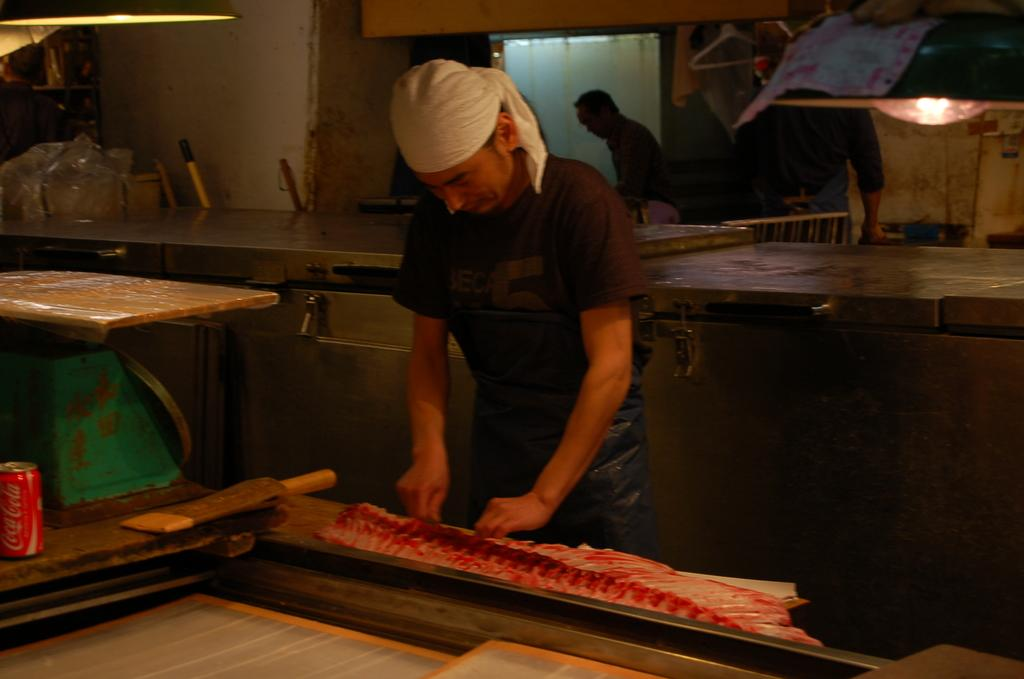What is the man in the image doing? The man in the image is cutting meat. What object can be seen on the table in the image? There is a tin on the table in the image. Can you describe the people in the background of the image? There are two people in the background of the image. What can be used to provide illumination in the image? There is a light in the image. What type of cracker is the goat playing with in the image? There is no goat or cracker present in the image. What musical instrument is the man playing while cutting the meat in the image? The image does not show the man playing any musical instrument while cutting the meat. 